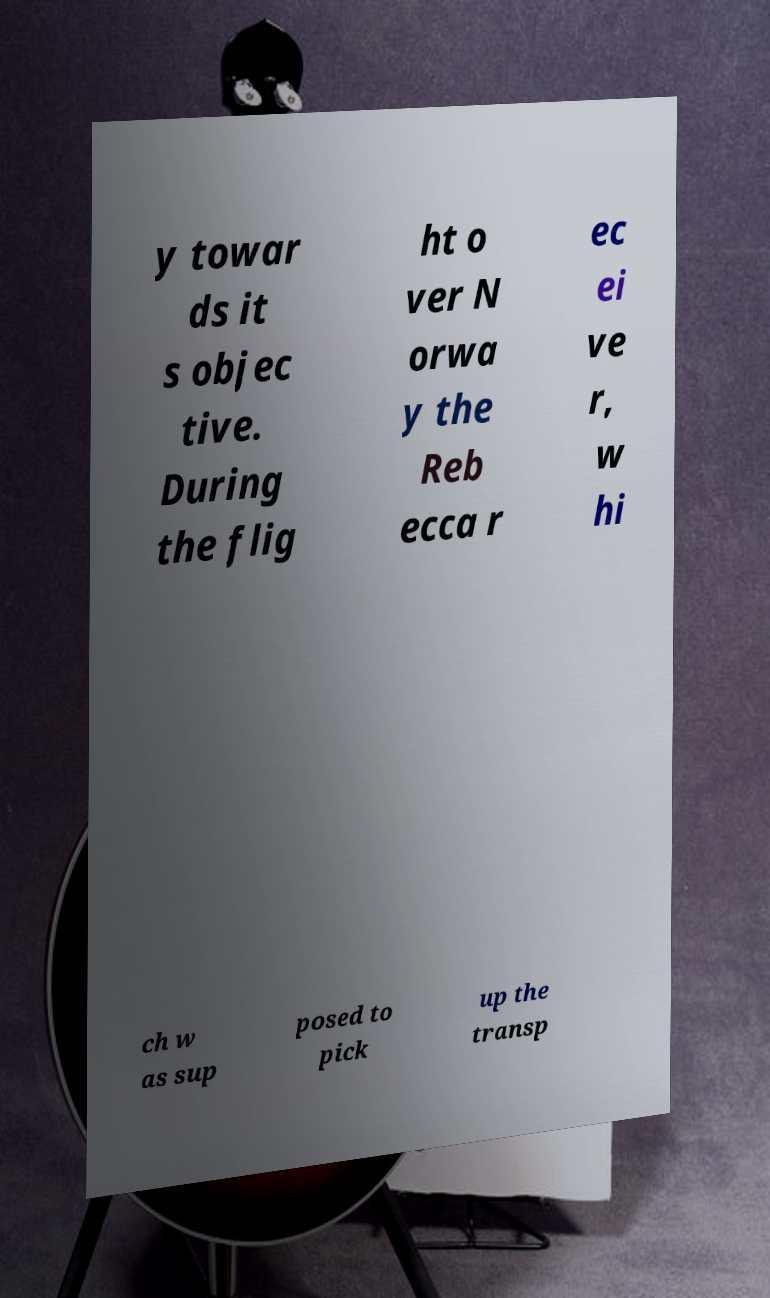Can you accurately transcribe the text from the provided image for me? y towar ds it s objec tive. During the flig ht o ver N orwa y the Reb ecca r ec ei ve r, w hi ch w as sup posed to pick up the transp 